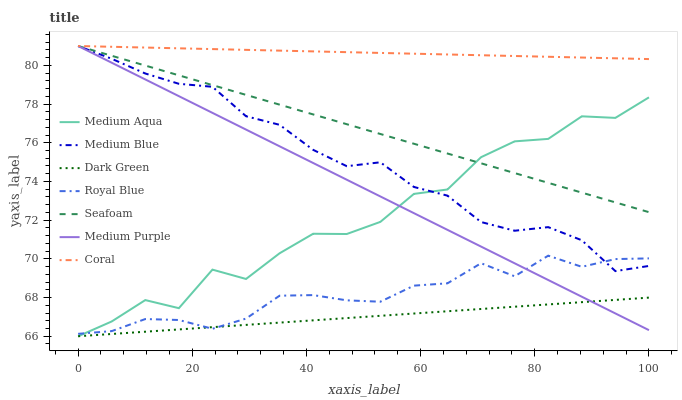Does Dark Green have the minimum area under the curve?
Answer yes or no. Yes. Does Coral have the maximum area under the curve?
Answer yes or no. Yes. Does Medium Blue have the minimum area under the curve?
Answer yes or no. No. Does Medium Blue have the maximum area under the curve?
Answer yes or no. No. Is Medium Purple the smoothest?
Answer yes or no. Yes. Is Medium Aqua the roughest?
Answer yes or no. Yes. Is Medium Blue the smoothest?
Answer yes or no. No. Is Medium Blue the roughest?
Answer yes or no. No. Does Medium Aqua have the lowest value?
Answer yes or no. Yes. Does Medium Blue have the lowest value?
Answer yes or no. No. Does Medium Purple have the highest value?
Answer yes or no. Yes. Does Royal Blue have the highest value?
Answer yes or no. No. Is Dark Green less than Seafoam?
Answer yes or no. Yes. Is Medium Blue greater than Dark Green?
Answer yes or no. Yes. Does Coral intersect Medium Blue?
Answer yes or no. Yes. Is Coral less than Medium Blue?
Answer yes or no. No. Is Coral greater than Medium Blue?
Answer yes or no. No. Does Dark Green intersect Seafoam?
Answer yes or no. No. 